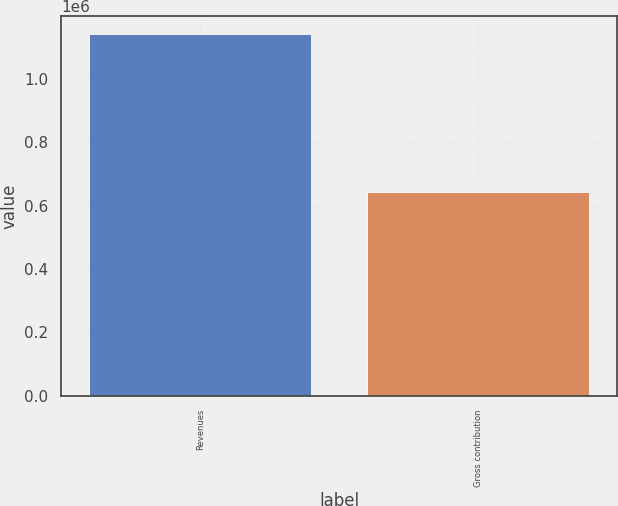Convert chart. <chart><loc_0><loc_0><loc_500><loc_500><bar_chart><fcel>Revenues<fcel>Gross contribution<nl><fcel>1.1398e+06<fcel>642906<nl></chart> 